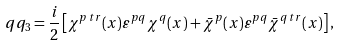<formula> <loc_0><loc_0><loc_500><loc_500>q q _ { 3 } = \frac { i } { 2 } \left [ \chi ^ { p \, t r } ( x ) \varepsilon ^ { p q } \chi ^ { q } ( x ) + \bar { \chi } ^ { p } ( x ) \varepsilon ^ { p q } \bar { \chi } ^ { q \, t r } ( x ) \right ] ,</formula> 